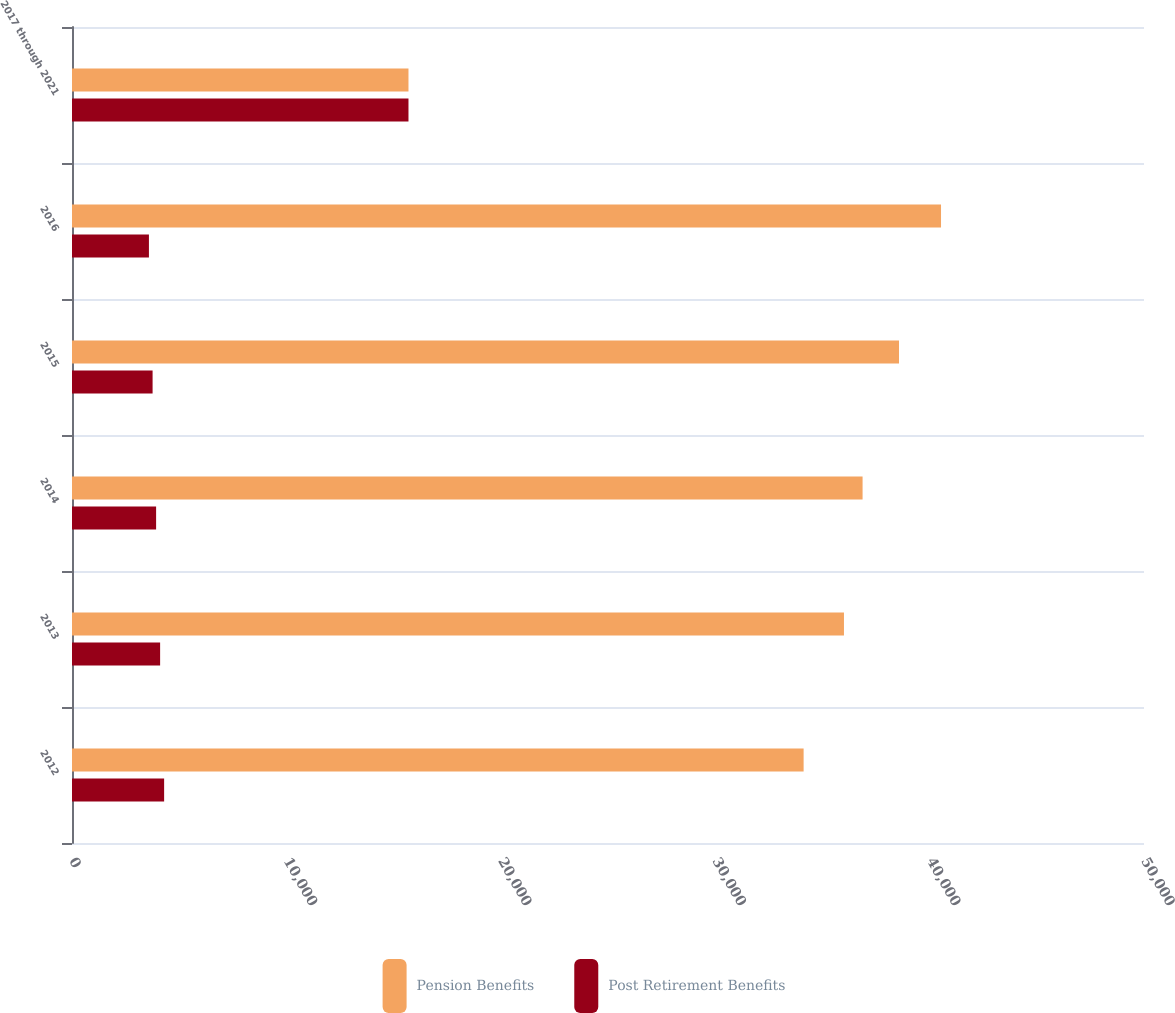Convert chart. <chart><loc_0><loc_0><loc_500><loc_500><stacked_bar_chart><ecel><fcel>2012<fcel>2013<fcel>2014<fcel>2015<fcel>2016<fcel>2017 through 2021<nl><fcel>Pension Benefits<fcel>34124<fcel>36006<fcel>36874<fcel>38573<fcel>40533<fcel>15694<nl><fcel>Post Retirement Benefits<fcel>4297<fcel>4110<fcel>3923<fcel>3759<fcel>3588<fcel>15694<nl></chart> 